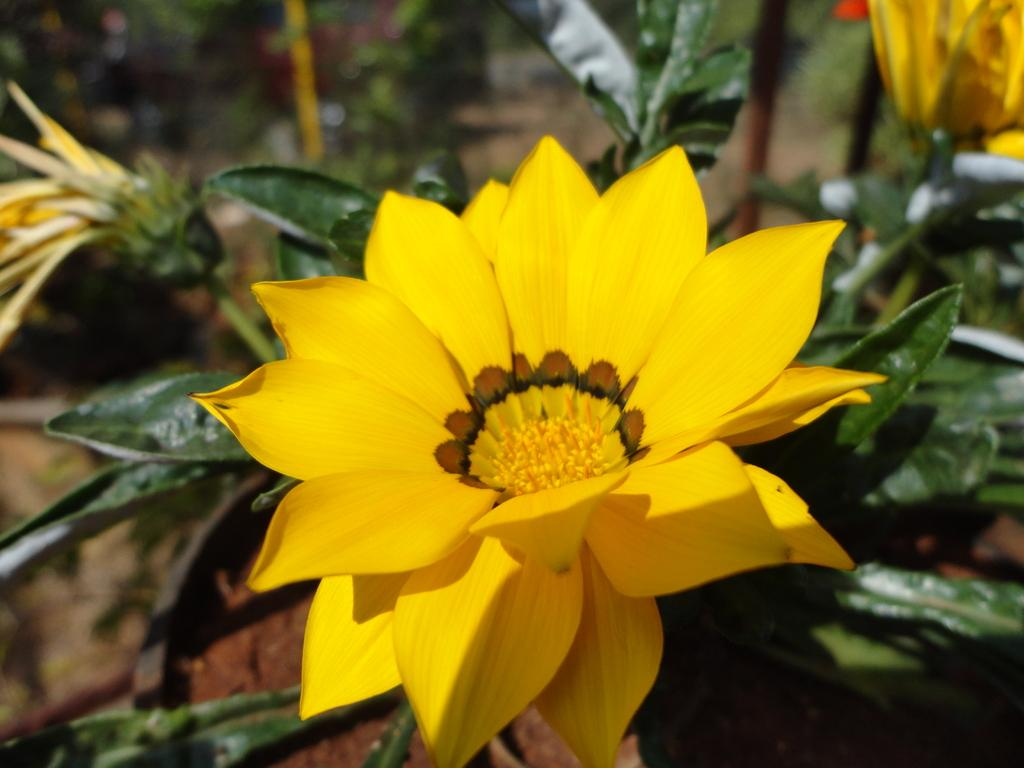What type of living organisms can be seen in the image? Plants can be seen in the image. Can you describe the flowers on the plants? Yes, there are yellow color flowers on the plants in the image. How many pins are holding the goat in the image? There is no goat present in the image, and therefore no pins holding it. 